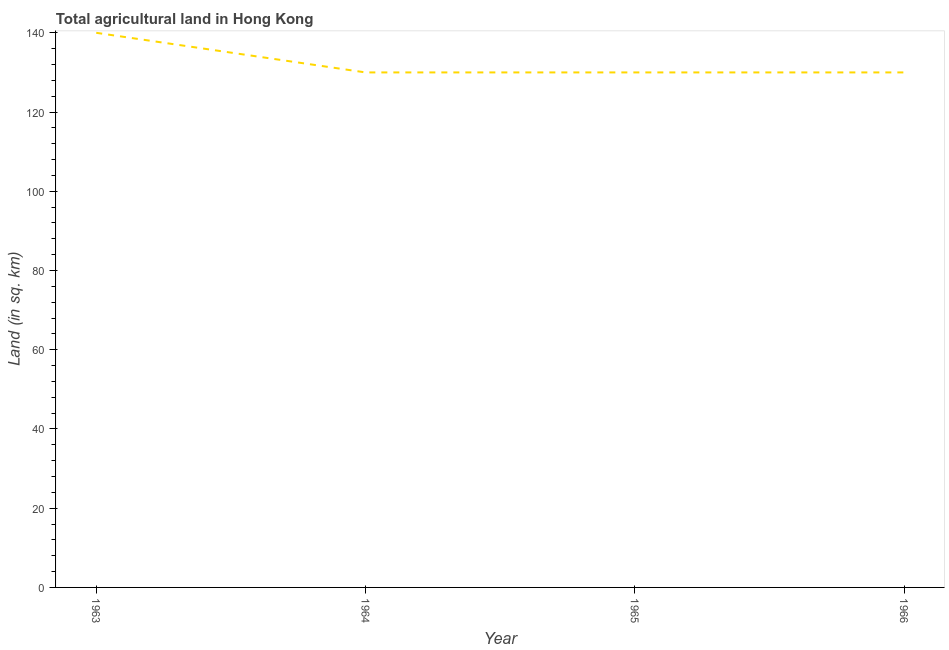What is the agricultural land in 1966?
Make the answer very short. 130. Across all years, what is the maximum agricultural land?
Provide a short and direct response. 140. Across all years, what is the minimum agricultural land?
Give a very brief answer. 130. In which year was the agricultural land maximum?
Your answer should be very brief. 1963. In which year was the agricultural land minimum?
Keep it short and to the point. 1964. What is the sum of the agricultural land?
Your answer should be compact. 530. What is the average agricultural land per year?
Your answer should be very brief. 132.5. What is the median agricultural land?
Your answer should be compact. 130. Do a majority of the years between 1964 and 1965 (inclusive) have agricultural land greater than 72 sq. km?
Offer a terse response. Yes. What is the ratio of the agricultural land in 1963 to that in 1964?
Give a very brief answer. 1.08. What is the difference between the highest and the second highest agricultural land?
Offer a very short reply. 10. What is the difference between the highest and the lowest agricultural land?
Ensure brevity in your answer.  10. Does the agricultural land monotonically increase over the years?
Ensure brevity in your answer.  No. How many years are there in the graph?
Provide a succinct answer. 4. Are the values on the major ticks of Y-axis written in scientific E-notation?
Provide a short and direct response. No. What is the title of the graph?
Provide a succinct answer. Total agricultural land in Hong Kong. What is the label or title of the X-axis?
Your answer should be compact. Year. What is the label or title of the Y-axis?
Your answer should be compact. Land (in sq. km). What is the Land (in sq. km) of 1963?
Ensure brevity in your answer.  140. What is the Land (in sq. km) in 1964?
Make the answer very short. 130. What is the Land (in sq. km) of 1965?
Your answer should be compact. 130. What is the Land (in sq. km) of 1966?
Offer a very short reply. 130. What is the difference between the Land (in sq. km) in 1963 and 1965?
Offer a very short reply. 10. What is the difference between the Land (in sq. km) in 1964 and 1965?
Your answer should be compact. 0. What is the difference between the Land (in sq. km) in 1965 and 1966?
Keep it short and to the point. 0. What is the ratio of the Land (in sq. km) in 1963 to that in 1964?
Offer a very short reply. 1.08. What is the ratio of the Land (in sq. km) in 1963 to that in 1965?
Provide a succinct answer. 1.08. What is the ratio of the Land (in sq. km) in 1963 to that in 1966?
Make the answer very short. 1.08. What is the ratio of the Land (in sq. km) in 1965 to that in 1966?
Provide a succinct answer. 1. 